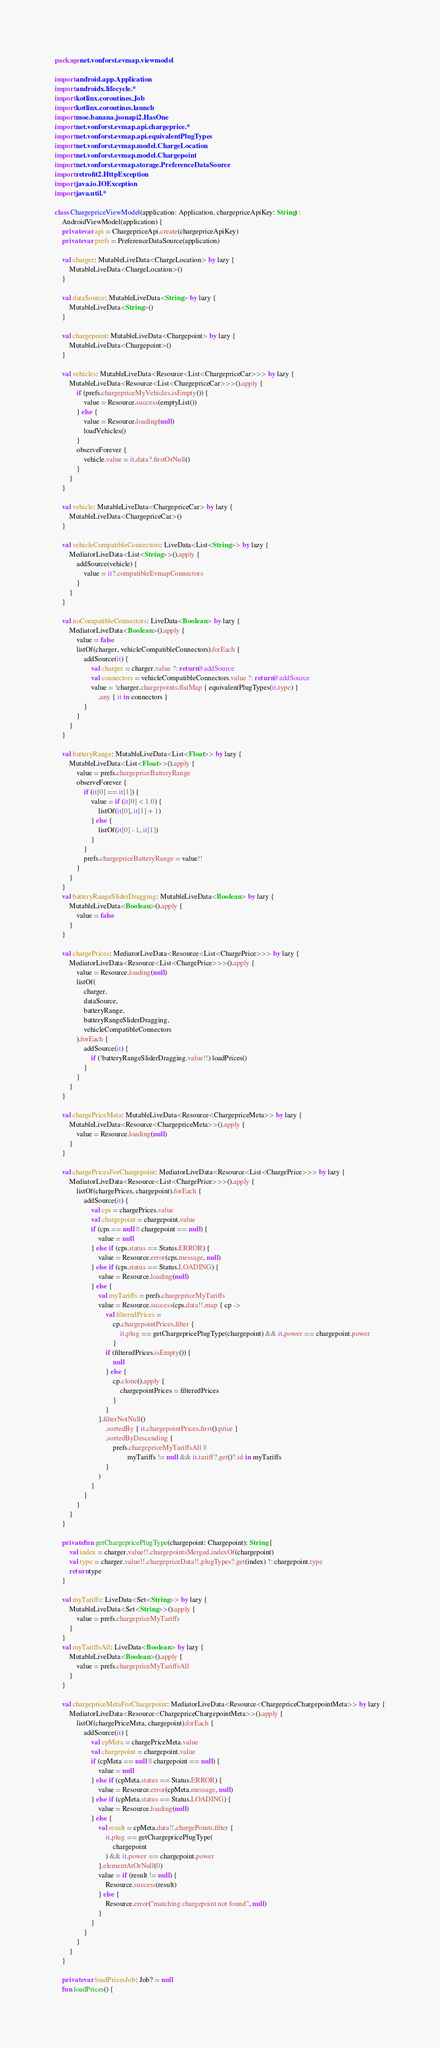<code> <loc_0><loc_0><loc_500><loc_500><_Kotlin_>package net.vonforst.evmap.viewmodel

import android.app.Application
import androidx.lifecycle.*
import kotlinx.coroutines.Job
import kotlinx.coroutines.launch
import moe.banana.jsonapi2.HasOne
import net.vonforst.evmap.api.chargeprice.*
import net.vonforst.evmap.api.equivalentPlugTypes
import net.vonforst.evmap.model.ChargeLocation
import net.vonforst.evmap.model.Chargepoint
import net.vonforst.evmap.storage.PreferenceDataSource
import retrofit2.HttpException
import java.io.IOException
import java.util.*

class ChargepriceViewModel(application: Application, chargepriceApiKey: String) :
    AndroidViewModel(application) {
    private var api = ChargepriceApi.create(chargepriceApiKey)
    private var prefs = PreferenceDataSource(application)

    val charger: MutableLiveData<ChargeLocation> by lazy {
        MutableLiveData<ChargeLocation>()
    }

    val dataSource: MutableLiveData<String> by lazy {
        MutableLiveData<String>()
    }

    val chargepoint: MutableLiveData<Chargepoint> by lazy {
        MutableLiveData<Chargepoint>()
    }

    val vehicles: MutableLiveData<Resource<List<ChargepriceCar>>> by lazy {
        MutableLiveData<Resource<List<ChargepriceCar>>>().apply {
            if (prefs.chargepriceMyVehicles.isEmpty()) {
                value = Resource.success(emptyList())
            } else {
                value = Resource.loading(null)
                loadVehicles()
            }
            observeForever {
                vehicle.value = it.data?.firstOrNull()
            }
        }
    }

    val vehicle: MutableLiveData<ChargepriceCar> by lazy {
        MutableLiveData<ChargepriceCar>()
    }

    val vehicleCompatibleConnectors: LiveData<List<String>> by lazy {
        MediatorLiveData<List<String>>().apply {
            addSource(vehicle) {
                value = it?.compatibleEvmapConnectors
            }
        }
    }

    val noCompatibleConnectors: LiveData<Boolean> by lazy {
        MediatorLiveData<Boolean>().apply {
            value = false
            listOf(charger, vehicleCompatibleConnectors).forEach {
                addSource(it) {
                    val charger = charger.value ?: return@addSource
                    val connectors = vehicleCompatibleConnectors.value ?: return@addSource
                    value = !charger.chargepoints.flatMap { equivalentPlugTypes(it.type) }
                        .any { it in connectors }
                }
            }
        }
    }

    val batteryRange: MutableLiveData<List<Float>> by lazy {
        MutableLiveData<List<Float>>().apply {
            value = prefs.chargepriceBatteryRange
            observeForever {
                if (it[0] == it[1]) {
                    value = if (it[0] < 1.0) {
                        listOf(it[0], it[1] + 1)
                    } else {
                        listOf(it[0] - 1, it[1])
                    }
                }
                prefs.chargepriceBatteryRange = value!!
            }
        }
    }
    val batteryRangeSliderDragging: MutableLiveData<Boolean> by lazy {
        MutableLiveData<Boolean>().apply {
            value = false
        }
    }

    val chargePrices: MediatorLiveData<Resource<List<ChargePrice>>> by lazy {
        MediatorLiveData<Resource<List<ChargePrice>>>().apply {
            value = Resource.loading(null)
            listOf(
                charger,
                dataSource,
                batteryRange,
                batteryRangeSliderDragging,
                vehicleCompatibleConnectors
            ).forEach {
                addSource(it) {
                    if (!batteryRangeSliderDragging.value!!) loadPrices()
                }
            }
        }
    }

    val chargePriceMeta: MutableLiveData<Resource<ChargepriceMeta>> by lazy {
        MutableLiveData<Resource<ChargepriceMeta>>().apply {
            value = Resource.loading(null)
        }
    }

    val chargePricesForChargepoint: MediatorLiveData<Resource<List<ChargePrice>>> by lazy {
        MediatorLiveData<Resource<List<ChargePrice>>>().apply {
            listOf(chargePrices, chargepoint).forEach {
                addSource(it) {
                    val cps = chargePrices.value
                    val chargepoint = chargepoint.value
                    if (cps == null || chargepoint == null) {
                        value = null
                    } else if (cps.status == Status.ERROR) {
                        value = Resource.error(cps.message, null)
                    } else if (cps.status == Status.LOADING) {
                        value = Resource.loading(null)
                    } else {
                        val myTariffs = prefs.chargepriceMyTariffs
                        value = Resource.success(cps.data!!.map { cp ->
                            val filteredPrices =
                                cp.chargepointPrices.filter {
                                    it.plug == getChargepricePlugType(chargepoint) && it.power == chargepoint.power
                                }
                            if (filteredPrices.isEmpty()) {
                                null
                            } else {
                                cp.clone().apply {
                                    chargepointPrices = filteredPrices
                                }
                            }
                        }.filterNotNull()
                            .sortedBy { it.chargepointPrices.first().price }
                            .sortedByDescending {
                                prefs.chargepriceMyTariffsAll ||
                                        myTariffs != null && it.tariff?.get()?.id in myTariffs
                            }
                        )
                    }
                }
            }
        }
    }

    private fun getChargepricePlugType(chargepoint: Chargepoint): String {
        val index = charger.value!!.chargepointsMerged.indexOf(chargepoint)
        val type = charger.value!!.chargepriceData!!.plugTypes?.get(index) ?: chargepoint.type
        return type
    }

    val myTariffs: LiveData<Set<String>> by lazy {
        MutableLiveData<Set<String>>().apply {
            value = prefs.chargepriceMyTariffs
        }
    }
    val myTariffsAll: LiveData<Boolean> by lazy {
        MutableLiveData<Boolean>().apply {
            value = prefs.chargepriceMyTariffsAll
        }
    }

    val chargepriceMetaForChargepoint: MediatorLiveData<Resource<ChargepriceChargepointMeta>> by lazy {
        MediatorLiveData<Resource<ChargepriceChargepointMeta>>().apply {
            listOf(chargePriceMeta, chargepoint).forEach {
                addSource(it) {
                    val cpMeta = chargePriceMeta.value
                    val chargepoint = chargepoint.value
                    if (cpMeta == null || chargepoint == null) {
                        value = null
                    } else if (cpMeta.status == Status.ERROR) {
                        value = Resource.error(cpMeta.message, null)
                    } else if (cpMeta.status == Status.LOADING) {
                        value = Resource.loading(null)
                    } else {
                        val result = cpMeta.data!!.chargePoints.filter {
                            it.plug == getChargepricePlugType(
                                chargepoint
                            ) && it.power == chargepoint.power
                        }.elementAtOrNull(0)
                        value = if (result != null) {
                            Resource.success(result)
                        } else {
                            Resource.error("matching chargepoint not found", null)
                        }
                    }
                }
            }
        }
    }

    private var loadPricesJob: Job? = null
    fun loadPrices() {</code> 